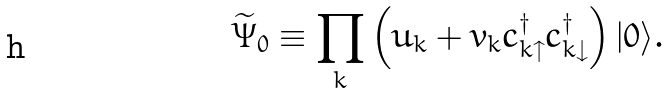<formula> <loc_0><loc_0><loc_500><loc_500>\widetilde { \Psi } _ { 0 } \equiv \prod _ { k } \left ( u _ { k } + v _ { k } c _ { k \uparrow } ^ { \dagger } c _ { k \downarrow } ^ { \dagger } \right ) | 0 \rangle .</formula> 